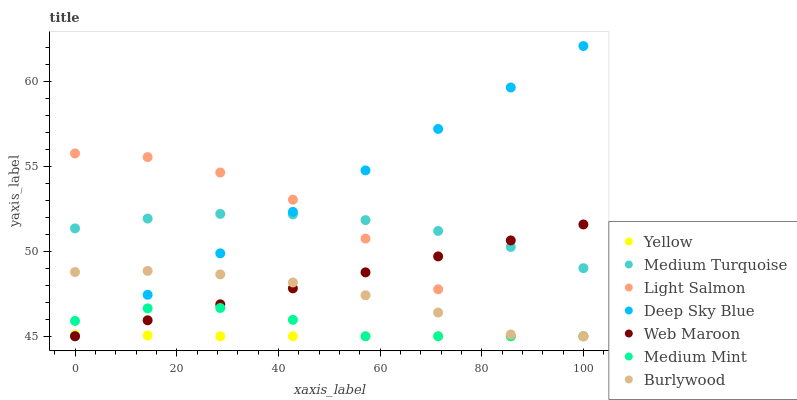Does Yellow have the minimum area under the curve?
Answer yes or no. Yes. Does Deep Sky Blue have the maximum area under the curve?
Answer yes or no. Yes. Does Light Salmon have the minimum area under the curve?
Answer yes or no. No. Does Light Salmon have the maximum area under the curve?
Answer yes or no. No. Is Web Maroon the smoothest?
Answer yes or no. Yes. Is Light Salmon the roughest?
Answer yes or no. Yes. Is Medium Turquoise the smoothest?
Answer yes or no. No. Is Medium Turquoise the roughest?
Answer yes or no. No. Does Medium Mint have the lowest value?
Answer yes or no. Yes. Does Medium Turquoise have the lowest value?
Answer yes or no. No. Does Deep Sky Blue have the highest value?
Answer yes or no. Yes. Does Light Salmon have the highest value?
Answer yes or no. No. Is Yellow less than Medium Turquoise?
Answer yes or no. Yes. Is Medium Turquoise greater than Burlywood?
Answer yes or no. Yes. Does Deep Sky Blue intersect Medium Mint?
Answer yes or no. Yes. Is Deep Sky Blue less than Medium Mint?
Answer yes or no. No. Is Deep Sky Blue greater than Medium Mint?
Answer yes or no. No. Does Yellow intersect Medium Turquoise?
Answer yes or no. No. 